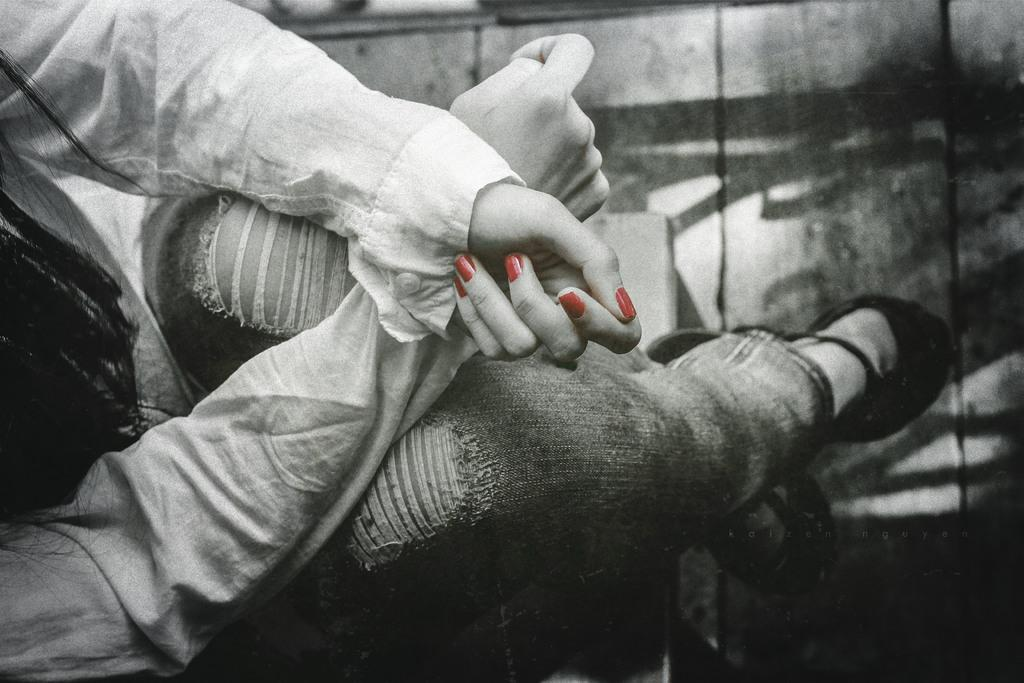Who is present in the image? There is a woman in the image. What is the woman doing in the image? The woman is sitting in a chair. What is the woman wearing in the image? She is wearing a white shirt and blue jeans. What type of flooring is visible in the image? There is a wooden floor in the image. Is there a volcano erupting in the background of the image? No, there is no volcano present in the image. What type of root can be seen growing from the woman's shirt? There are no roots visible in the image, as the woman is wearing a shirt and jeans. 